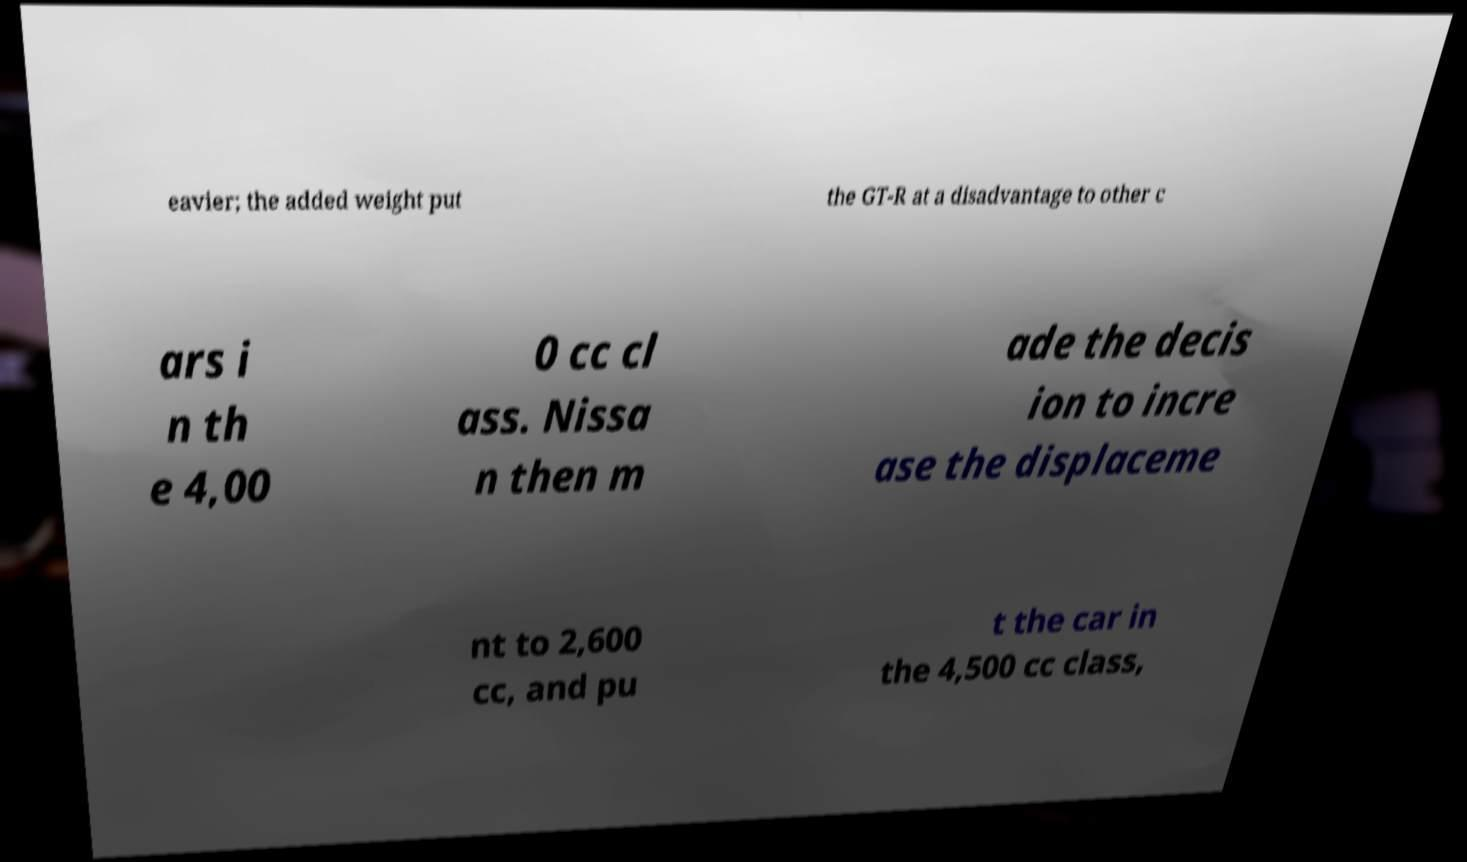Can you read and provide the text displayed in the image?This photo seems to have some interesting text. Can you extract and type it out for me? eavier; the added weight put the GT-R at a disadvantage to other c ars i n th e 4,00 0 cc cl ass. Nissa n then m ade the decis ion to incre ase the displaceme nt to 2,600 cc, and pu t the car in the 4,500 cc class, 